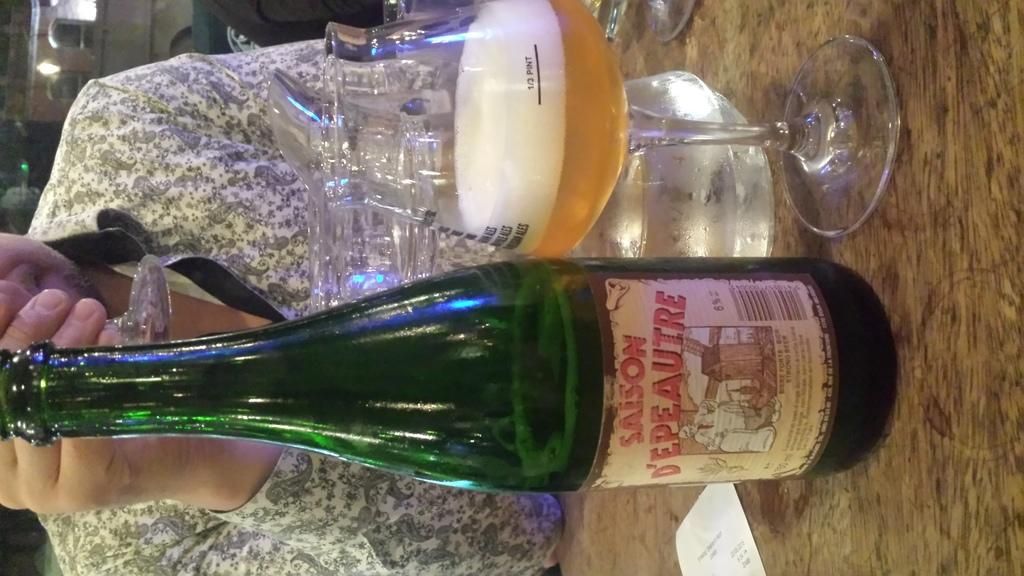<image>
Provide a brief description of the given image. A green bottle of Saison D'epeautre is siting next to a wine glass. 